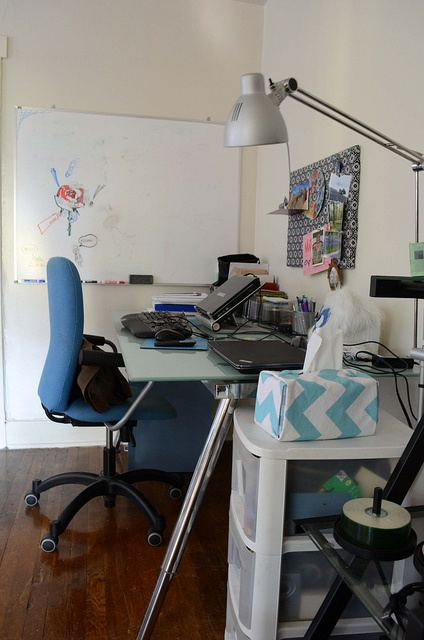Describe the objects in this image and their specific colors. I can see chair in darkgray, black, gray, and maroon tones, laptop in darkgray, black, and gray tones, keyboard in darkgray, black, and gray tones, laptop in darkgray, gray, and black tones, and mouse in darkgray, black, and gray tones in this image. 